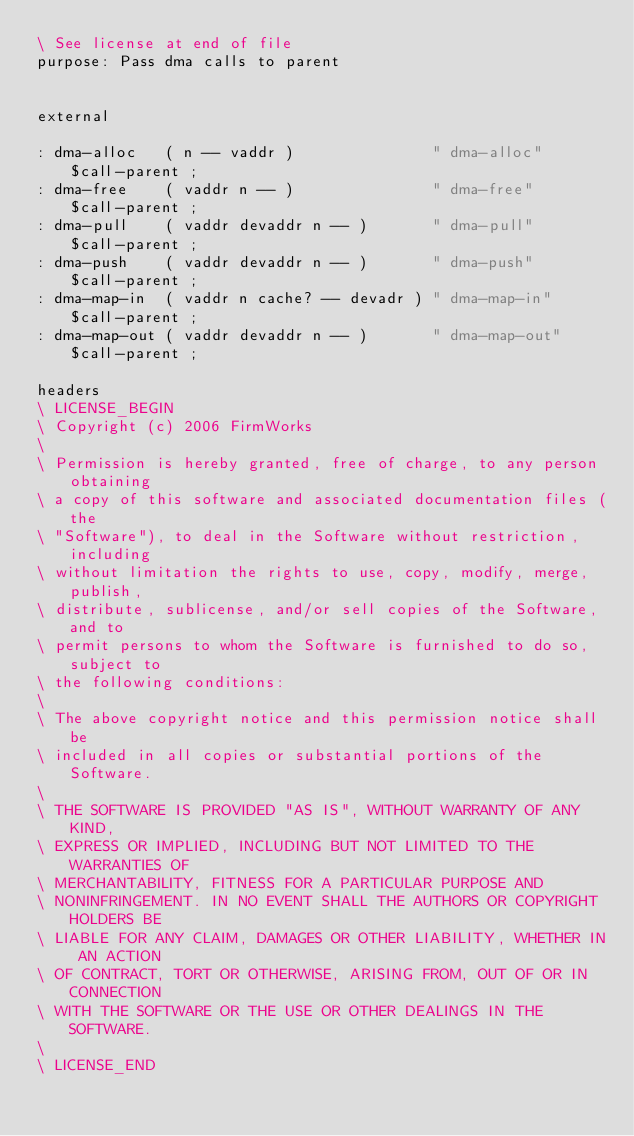Convert code to text. <code><loc_0><loc_0><loc_500><loc_500><_Forth_>\ See license at end of file
purpose: Pass dma calls to parent


external

: dma-alloc   ( n -- vaddr )               " dma-alloc"   $call-parent ;
: dma-free    ( vaddr n -- )               " dma-free"    $call-parent ;
: dma-pull    ( vaddr devaddr n -- )       " dma-pull"    $call-parent ;
: dma-push    ( vaddr devaddr n -- )       " dma-push"    $call-parent ;
: dma-map-in  ( vaddr n cache? -- devadr ) " dma-map-in"  $call-parent ;
: dma-map-out ( vaddr devaddr n -- )       " dma-map-out" $call-parent ;

headers
\ LICENSE_BEGIN
\ Copyright (c) 2006 FirmWorks
\ 
\ Permission is hereby granted, free of charge, to any person obtaining
\ a copy of this software and associated documentation files (the
\ "Software"), to deal in the Software without restriction, including
\ without limitation the rights to use, copy, modify, merge, publish,
\ distribute, sublicense, and/or sell copies of the Software, and to
\ permit persons to whom the Software is furnished to do so, subject to
\ the following conditions:
\ 
\ The above copyright notice and this permission notice shall be
\ included in all copies or substantial portions of the Software.
\ 
\ THE SOFTWARE IS PROVIDED "AS IS", WITHOUT WARRANTY OF ANY KIND,
\ EXPRESS OR IMPLIED, INCLUDING BUT NOT LIMITED TO THE WARRANTIES OF
\ MERCHANTABILITY, FITNESS FOR A PARTICULAR PURPOSE AND
\ NONINFRINGEMENT. IN NO EVENT SHALL THE AUTHORS OR COPYRIGHT HOLDERS BE
\ LIABLE FOR ANY CLAIM, DAMAGES OR OTHER LIABILITY, WHETHER IN AN ACTION
\ OF CONTRACT, TORT OR OTHERWISE, ARISING FROM, OUT OF OR IN CONNECTION
\ WITH THE SOFTWARE OR THE USE OR OTHER DEALINGS IN THE SOFTWARE.
\
\ LICENSE_END
</code> 